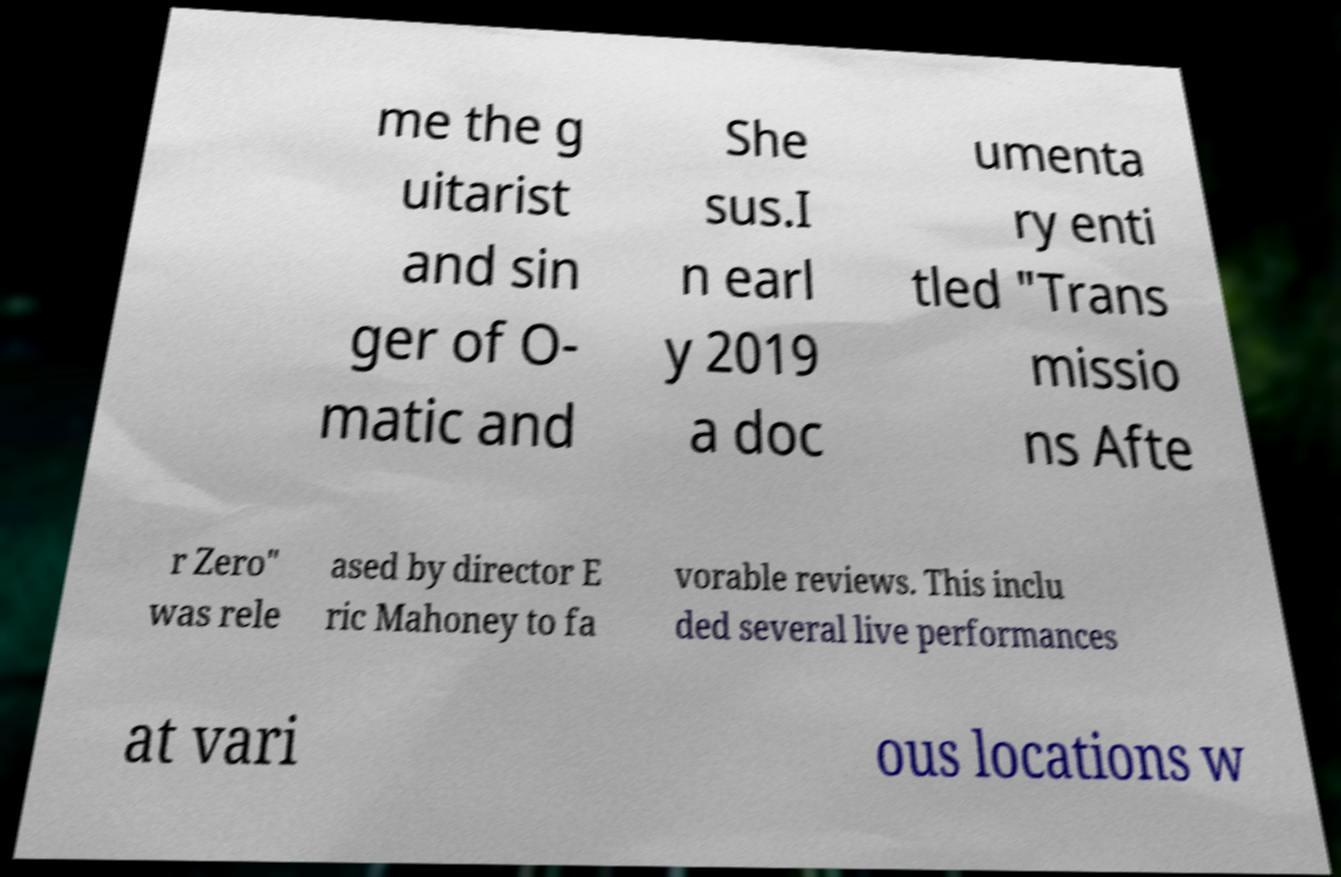Please identify and transcribe the text found in this image. me the g uitarist and sin ger of O- matic and She sus.I n earl y 2019 a doc umenta ry enti tled "Trans missio ns Afte r Zero" was rele ased by director E ric Mahoney to fa vorable reviews. This inclu ded several live performances at vari ous locations w 